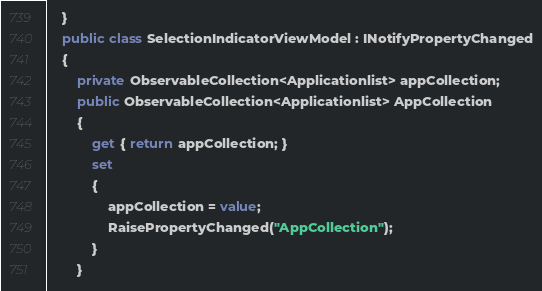<code> <loc_0><loc_0><loc_500><loc_500><_C#_>	}
	public class SelectionIndicatorViewModel : INotifyPropertyChanged
	{
		private ObservableCollection<Applicationlist> appCollection;
		public ObservableCollection<Applicationlist> AppCollection
		{
			get { return appCollection; }
			set
			{
				appCollection = value;
				RaisePropertyChanged("AppCollection");
			}
		}
</code> 